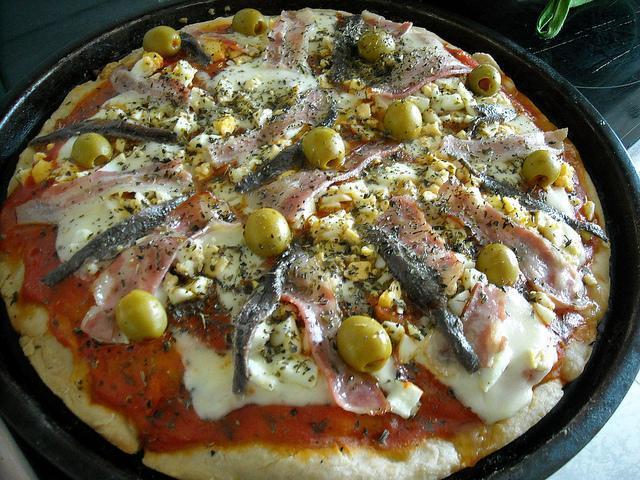How many horses with a white stomach are there?
Give a very brief answer. 0. 